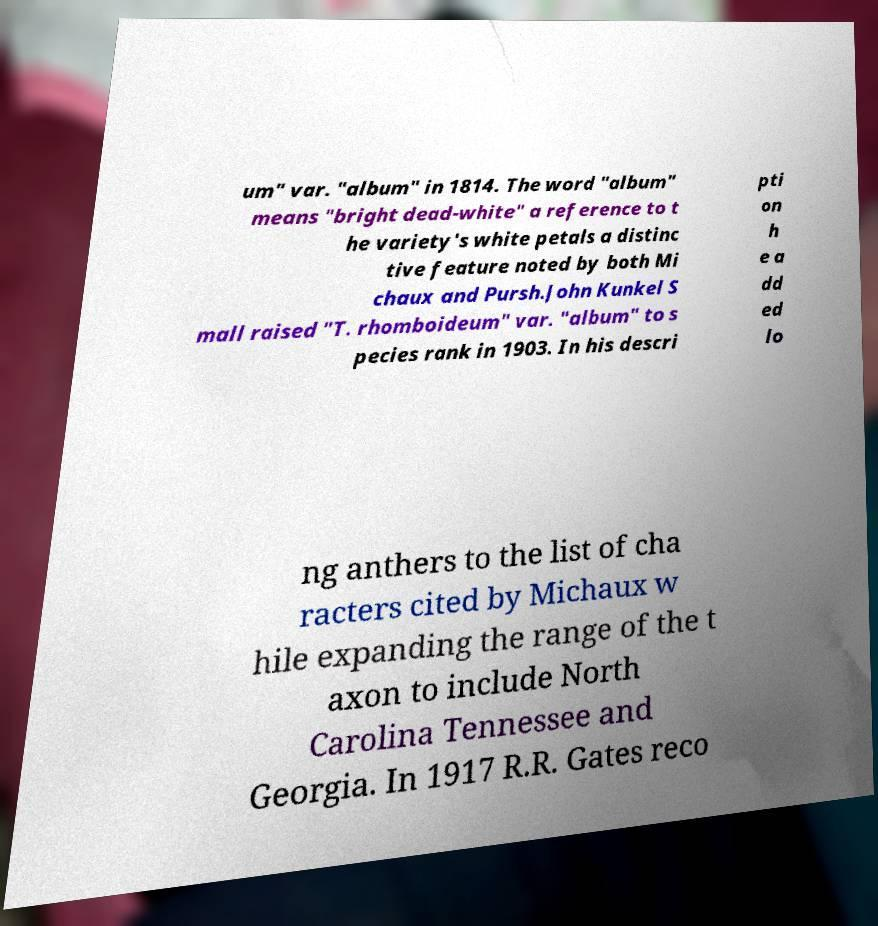There's text embedded in this image that I need extracted. Can you transcribe it verbatim? um" var. "album" in 1814. The word "album" means "bright dead-white" a reference to t he variety's white petals a distinc tive feature noted by both Mi chaux and Pursh.John Kunkel S mall raised "T. rhomboideum" var. "album" to s pecies rank in 1903. In his descri pti on h e a dd ed lo ng anthers to the list of cha racters cited by Michaux w hile expanding the range of the t axon to include North Carolina Tennessee and Georgia. In 1917 R.R. Gates reco 